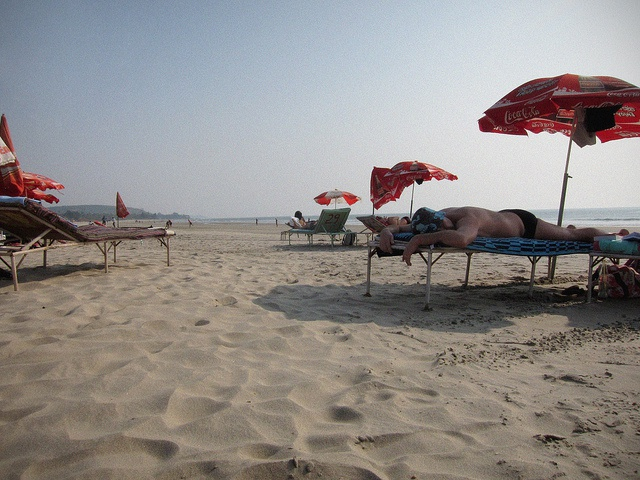Describe the objects in this image and their specific colors. I can see umbrella in gray, maroon, black, and brown tones, people in gray, black, and maroon tones, chair in gray, black, and maroon tones, chair in gray, black, navy, and blue tones, and backpack in gray, black, and maroon tones in this image. 